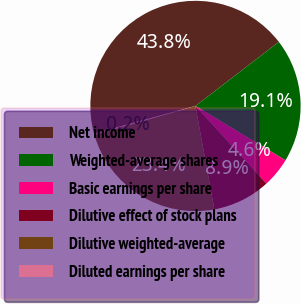Convert chart. <chart><loc_0><loc_0><loc_500><loc_500><pie_chart><fcel>Net income<fcel>Weighted-average shares<fcel>Basic earnings per share<fcel>Dilutive effect of stock plans<fcel>Dilutive weighted-average<fcel>Diluted earnings per share<nl><fcel>43.81%<fcel>19.08%<fcel>4.56%<fcel>8.92%<fcel>23.44%<fcel>0.2%<nl></chart> 